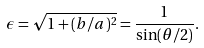<formula> <loc_0><loc_0><loc_500><loc_500>\epsilon = \sqrt { 1 + ( b / a ) ^ { 2 } } = \frac { 1 } { \sin ( \theta / 2 ) } .</formula> 